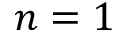<formula> <loc_0><loc_0><loc_500><loc_500>n = 1</formula> 